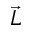<formula> <loc_0><loc_0><loc_500><loc_500>\vec { L }</formula> 